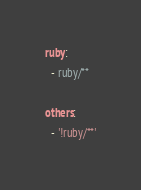Convert code to text. <code><loc_0><loc_0><loc_500><loc_500><_YAML_>ruby:
  - ruby/**

others:
  - '!ruby/**'
</code> 